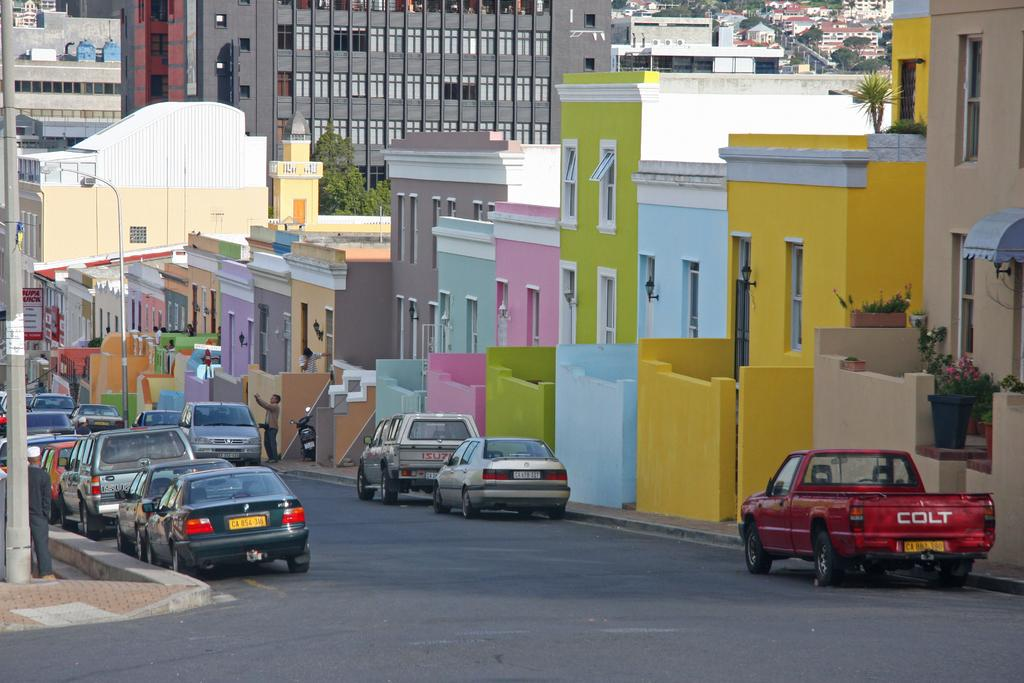<image>
Write a terse but informative summary of the picture. Brightly colored stuco houses on a street with cars and the last one is a Colt. 